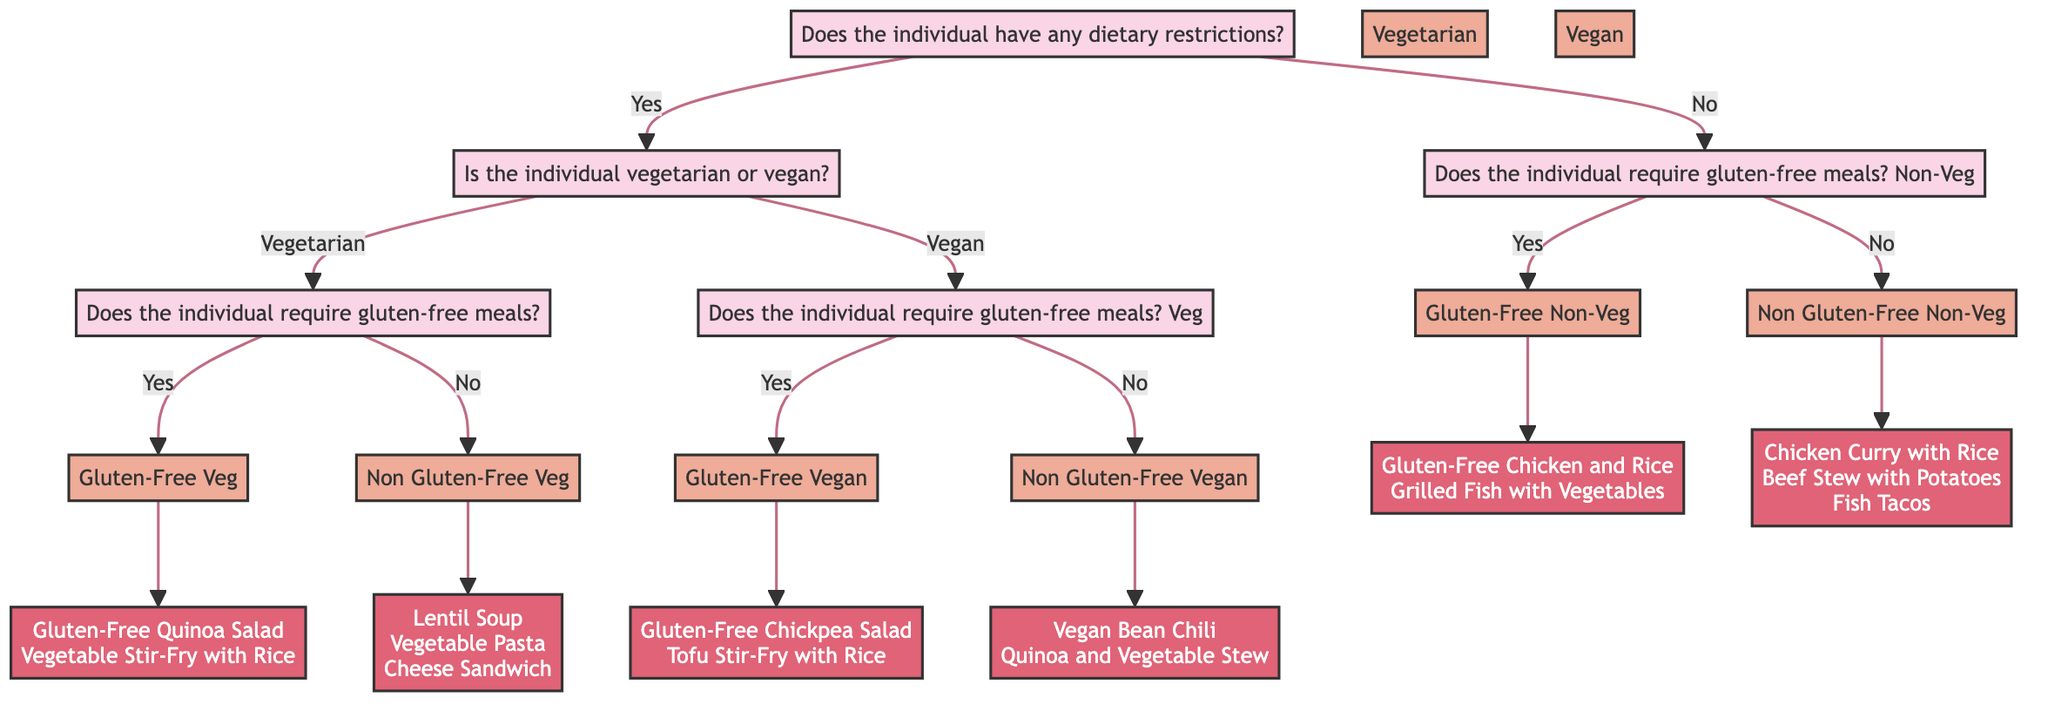Does the individual have any dietary restrictions? This is the first question in the decision tree, determining whether to follow the dietary restriction path. If the answer is yes, the next question is about being vegetarian or vegan.
Answer: Yes What is the next question if the individual is vegetarian? If the individual answers that they have dietary restrictions and are vegetarian, the diagram directs to the next question focused on gluten-free meal requirements.
Answer: Does the individual require gluten-free meals? How many meal options are available for gluten-free vegetarians? If a vegetarian requires gluten-free meals, the decision tree specifies two meal options that cater to this dietary need.
Answer: 2 What meal options are provided for non-vegetarians who require gluten-free meals? The non-vegetarian path for gluten-free meal requirements leads to two specified meal options.
Answer: Gluten-Free Chicken and Rice, Grilled Fish with Vegetables What is the final outcome if a person has no dietary restrictions and requires gluten-free meals? If an individual with no dietary restrictions requires gluten-free meals, the decision tree presents two suitable meal options specifically catered to them.
Answer: Gluten-Free Chicken and Rice, Grilled Fish with Vegetables What is the first meal option listed for vegan individuals? The decision tree offers different meal options for vegan individuals; the first option listed for vegans who do not require gluten-free meals is vegan bean chili.
Answer: Vegan Bean Chili 